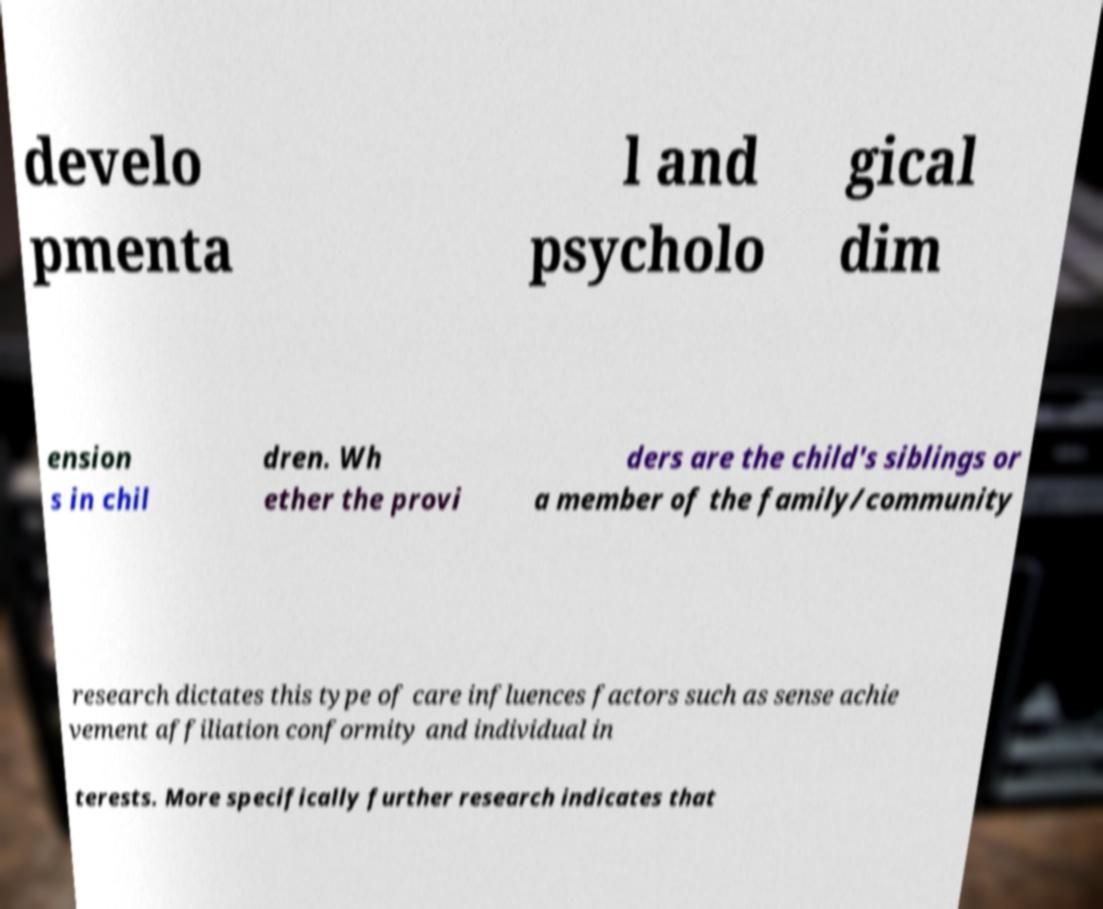There's text embedded in this image that I need extracted. Can you transcribe it verbatim? develo pmenta l and psycholo gical dim ension s in chil dren. Wh ether the provi ders are the child's siblings or a member of the family/community research dictates this type of care influences factors such as sense achie vement affiliation conformity and individual in terests. More specifically further research indicates that 